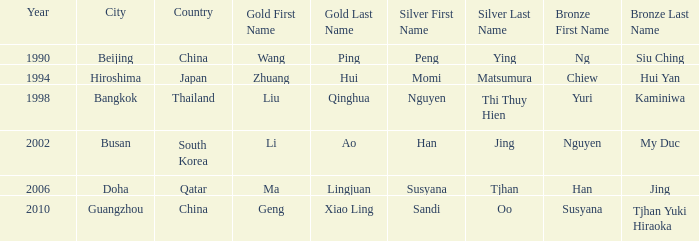What Silver has a Golf of Li AO? Han Jing. Would you be able to parse every entry in this table? {'header': ['Year', 'City', 'Country', 'Gold First Name', 'Gold Last Name', 'Silver First Name', 'Silver Last Name', 'Bronze First Name', 'Bronze Last Name'], 'rows': [['1990', 'Beijing', 'China', 'Wang', 'Ping', 'Peng', 'Ying', 'Ng', 'Siu Ching'], ['1994', 'Hiroshima', 'Japan', 'Zhuang', 'Hui', 'Momi', 'Matsumura', 'Chiew', 'Hui Yan'], ['1998', 'Bangkok', 'Thailand', 'Liu', 'Qinghua', 'Nguyen', 'Thi Thuy Hien', 'Yuri', 'Kaminiwa'], ['2002', 'Busan', 'South Korea', 'Li', 'Ao', 'Han', 'Jing', 'Nguyen', 'My Duc'], ['2006', 'Doha', 'Qatar', 'Ma', 'Lingjuan', 'Susyana', 'Tjhan', 'Han', 'Jing'], ['2010', 'Guangzhou', 'China', 'Geng', 'Xiao Ling', 'Sandi', 'Oo', 'Susyana', 'Tjhan Yuki Hiraoka']]} 